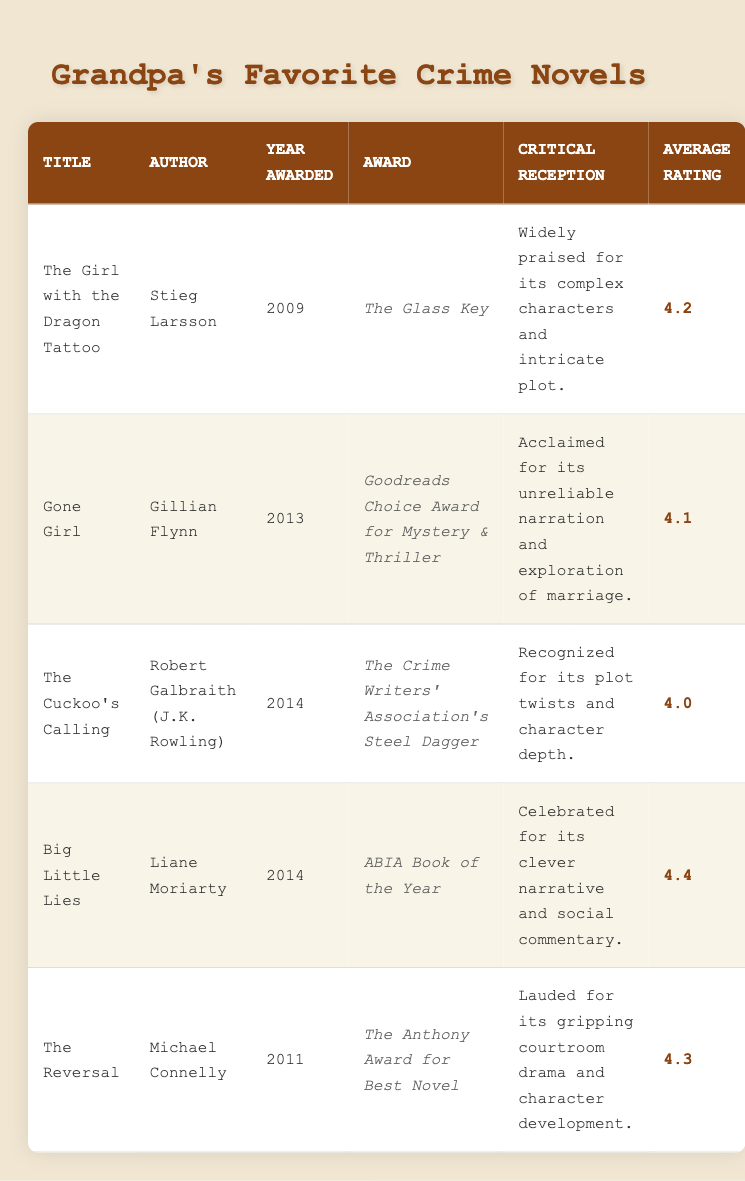What is the title of the novel that won the Glass Key award? The novel that won the Glass Key award is "The Girl with the Dragon Tattoo." I searched the "Award" column for the Glass Key award and identified the corresponding "Title" which is "The Girl with the Dragon Tattoo."
Answer: The Girl with the Dragon Tattoo Which author received an award for the novel published in 2014 that has the highest average rating? The novel with the highest average rating in 2014 is "Big Little Lies" by Liane Moriarty, which has an average rating of 4.4. I compared the average ratings of both novels released in 2014, namely "The Cuckoo's Calling" and "Big Little Lies."
Answer: Liane Moriarty Is "Gone Girl" critically acclaimed for its unreliable narration? Yes, "Gone Girl" is acclaimed for its unreliable narration and exploration of marriage as mentioned in its critical reception. I checked the "Title" for "Gone Girl" and referred to the "Critical Reception" column for confirmation.
Answer: Yes What is the average rating of the books awarded in 2014? To find the average rating, I included the two novels from 2014: "The Cuckoo's Calling" (4.0) and "Big Little Lies" (4.4). Summing these ratings gives 4.0 + 4.4 = 8.4. Dividing this by the number of novels (2) results in an average of 8.4 / 2 = 4.2.
Answer: 4.2 Who is the author of the novel that won the Anthony Award for Best Novel? The author who won the Anthony Award for Best Novel is Michael Connelly for his novel "The Reversal." I located "The Anthony Award for Best Novel" in the "Award" column and cross-referenced it with the "Author" column.
Answer: Michael Connelly 